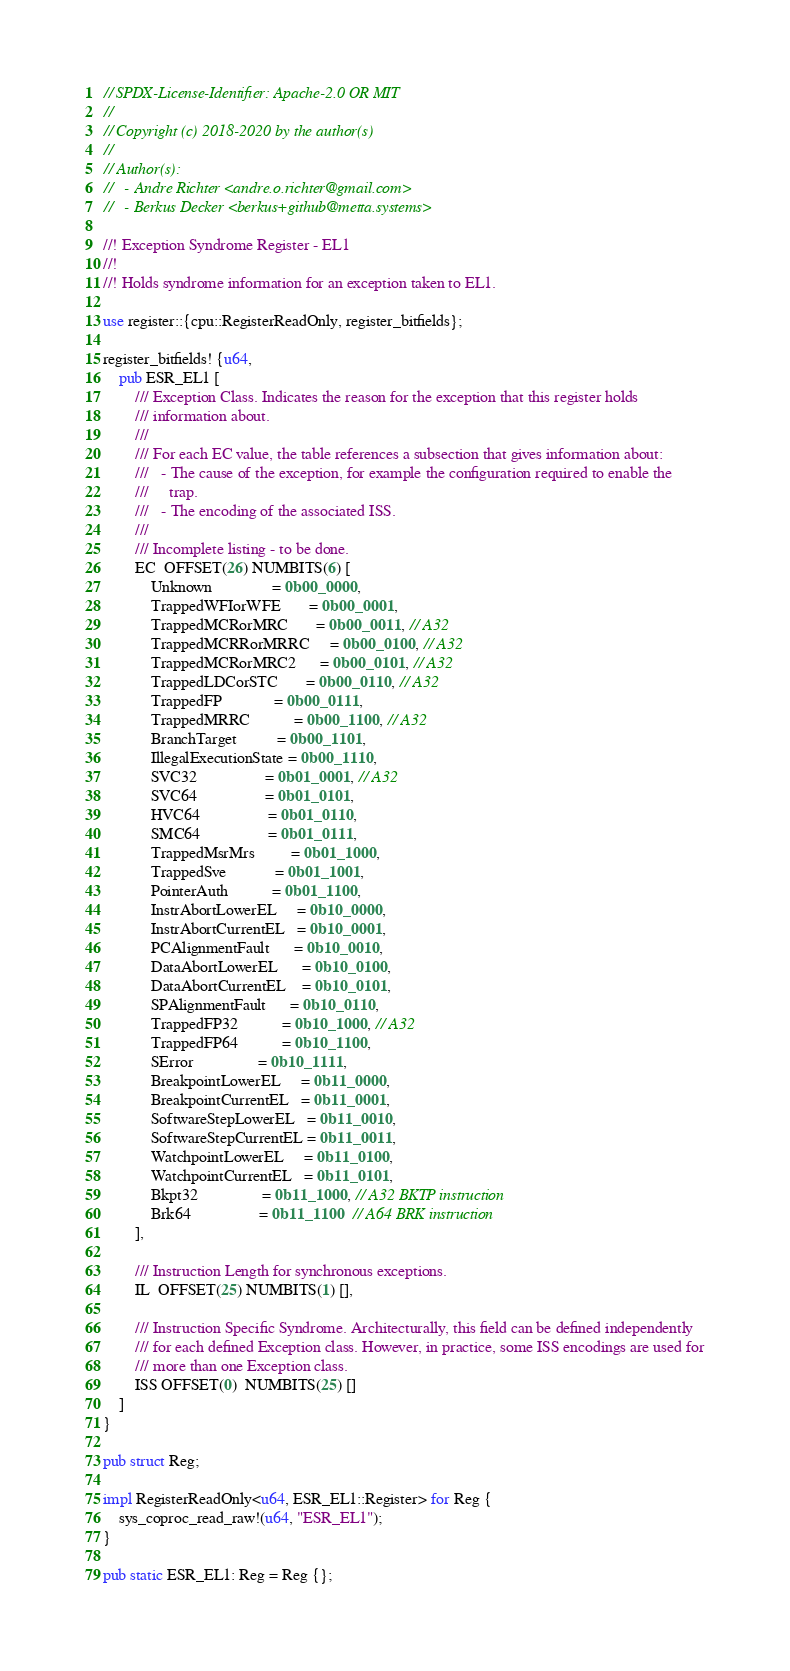<code> <loc_0><loc_0><loc_500><loc_500><_Rust_>// SPDX-License-Identifier: Apache-2.0 OR MIT
//
// Copyright (c) 2018-2020 by the author(s)
//
// Author(s):
//   - Andre Richter <andre.o.richter@gmail.com>
//   - Berkus Decker <berkus+github@metta.systems>

//! Exception Syndrome Register - EL1
//!
//! Holds syndrome information for an exception taken to EL1.

use register::{cpu::RegisterReadOnly, register_bitfields};

register_bitfields! {u64,
    pub ESR_EL1 [
        /// Exception Class. Indicates the reason for the exception that this register holds
        /// information about.
        ///
        /// For each EC value, the table references a subsection that gives information about:
        ///   - The cause of the exception, for example the configuration required to enable the
        ///     trap.
        ///   - The encoding of the associated ISS.
        ///
        /// Incomplete listing - to be done.
        EC  OFFSET(26) NUMBITS(6) [
            Unknown               = 0b00_0000,
            TrappedWFIorWFE       = 0b00_0001,
            TrappedMCRorMRC       = 0b00_0011, // A32
            TrappedMCRRorMRRC     = 0b00_0100, // A32
            TrappedMCRorMRC2      = 0b00_0101, // A32
            TrappedLDCorSTC       = 0b00_0110, // A32
            TrappedFP             = 0b00_0111,
            TrappedMRRC           = 0b00_1100, // A32
            BranchTarget          = 0b00_1101,
            IllegalExecutionState = 0b00_1110,
            SVC32                 = 0b01_0001, // A32
            SVC64                 = 0b01_0101,
            HVC64                 = 0b01_0110,
            SMC64                 = 0b01_0111,
            TrappedMsrMrs         = 0b01_1000,
            TrappedSve            = 0b01_1001,
            PointerAuth           = 0b01_1100,
            InstrAbortLowerEL     = 0b10_0000,
            InstrAbortCurrentEL   = 0b10_0001,
            PCAlignmentFault      = 0b10_0010,
            DataAbortLowerEL      = 0b10_0100,
            DataAbortCurrentEL    = 0b10_0101,
            SPAlignmentFault      = 0b10_0110,
            TrappedFP32           = 0b10_1000, // A32
            TrappedFP64           = 0b10_1100,
            SError                = 0b10_1111,
            BreakpointLowerEL     = 0b11_0000,
            BreakpointCurrentEL   = 0b11_0001,
            SoftwareStepLowerEL   = 0b11_0010,
            SoftwareStepCurrentEL = 0b11_0011,
            WatchpointLowerEL     = 0b11_0100,
            WatchpointCurrentEL   = 0b11_0101,
            Bkpt32                = 0b11_1000, // A32 BKTP instruction
            Brk64                 = 0b11_1100  // A64 BRK instruction
        ],

        /// Instruction Length for synchronous exceptions.
        IL  OFFSET(25) NUMBITS(1) [],

        /// Instruction Specific Syndrome. Architecturally, this field can be defined independently
        /// for each defined Exception class. However, in practice, some ISS encodings are used for
        /// more than one Exception class.
        ISS OFFSET(0)  NUMBITS(25) []
    ]
}

pub struct Reg;

impl RegisterReadOnly<u64, ESR_EL1::Register> for Reg {
    sys_coproc_read_raw!(u64, "ESR_EL1");
}

pub static ESR_EL1: Reg = Reg {};
</code> 